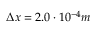Convert formula to latex. <formula><loc_0><loc_0><loc_500><loc_500>\Delta x = 2 . 0 \cdot 1 0 ^ { - 4 } m</formula> 